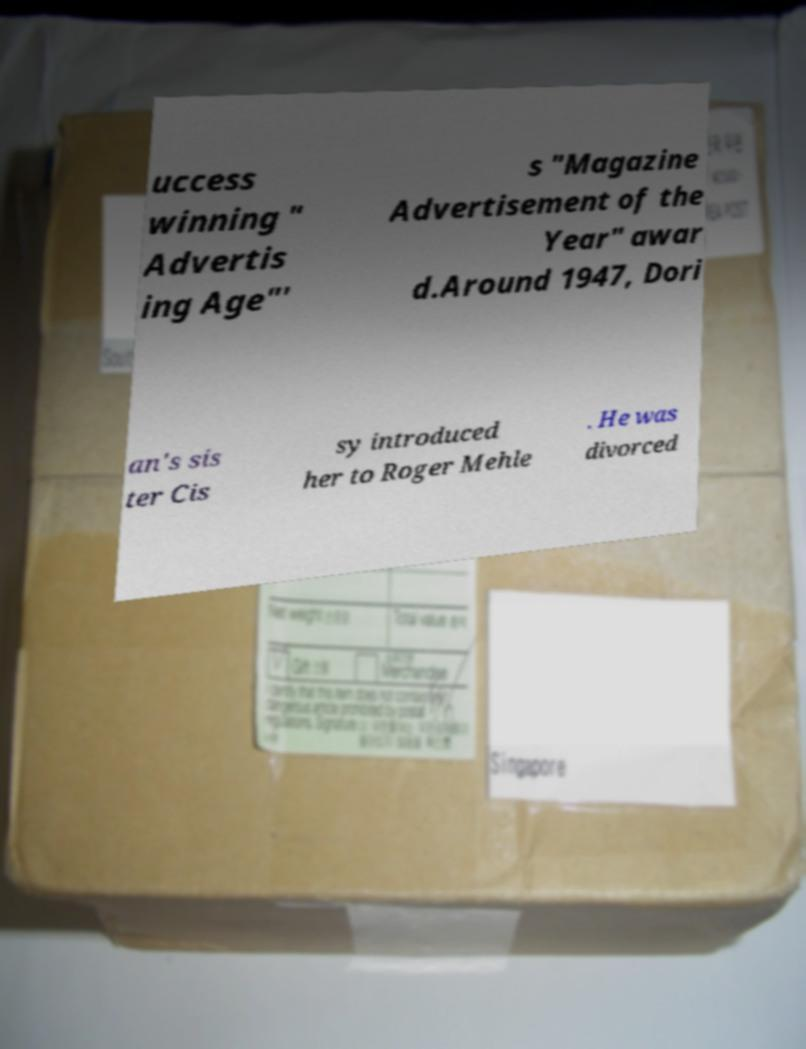Can you read and provide the text displayed in the image?This photo seems to have some interesting text. Can you extract and type it out for me? uccess winning " Advertis ing Age"' s "Magazine Advertisement of the Year" awar d.Around 1947, Dori an's sis ter Cis sy introduced her to Roger Mehle . He was divorced 